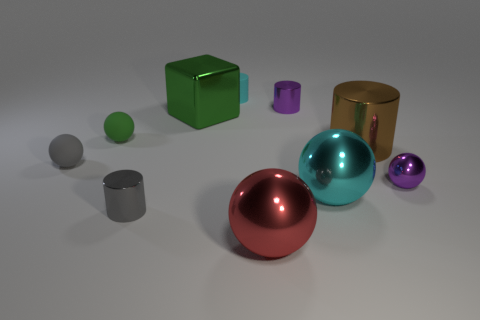Subtract all cylinders. How many objects are left? 6 Add 3 green rubber objects. How many green rubber objects exist? 4 Subtract 0 red cylinders. How many objects are left? 10 Subtract all blue metallic objects. Subtract all red metallic objects. How many objects are left? 9 Add 3 big green objects. How many big green objects are left? 4 